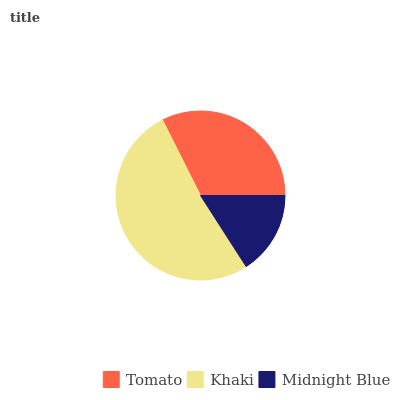Is Midnight Blue the minimum?
Answer yes or no. Yes. Is Khaki the maximum?
Answer yes or no. Yes. Is Khaki the minimum?
Answer yes or no. No. Is Midnight Blue the maximum?
Answer yes or no. No. Is Khaki greater than Midnight Blue?
Answer yes or no. Yes. Is Midnight Blue less than Khaki?
Answer yes or no. Yes. Is Midnight Blue greater than Khaki?
Answer yes or no. No. Is Khaki less than Midnight Blue?
Answer yes or no. No. Is Tomato the high median?
Answer yes or no. Yes. Is Tomato the low median?
Answer yes or no. Yes. Is Khaki the high median?
Answer yes or no. No. Is Midnight Blue the low median?
Answer yes or no. No. 